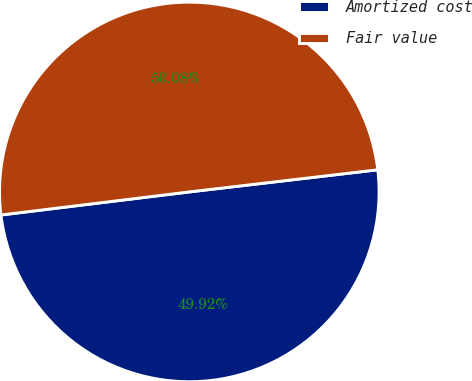Convert chart to OTSL. <chart><loc_0><loc_0><loc_500><loc_500><pie_chart><fcel>Amortized cost<fcel>Fair value<nl><fcel>49.92%<fcel>50.08%<nl></chart> 